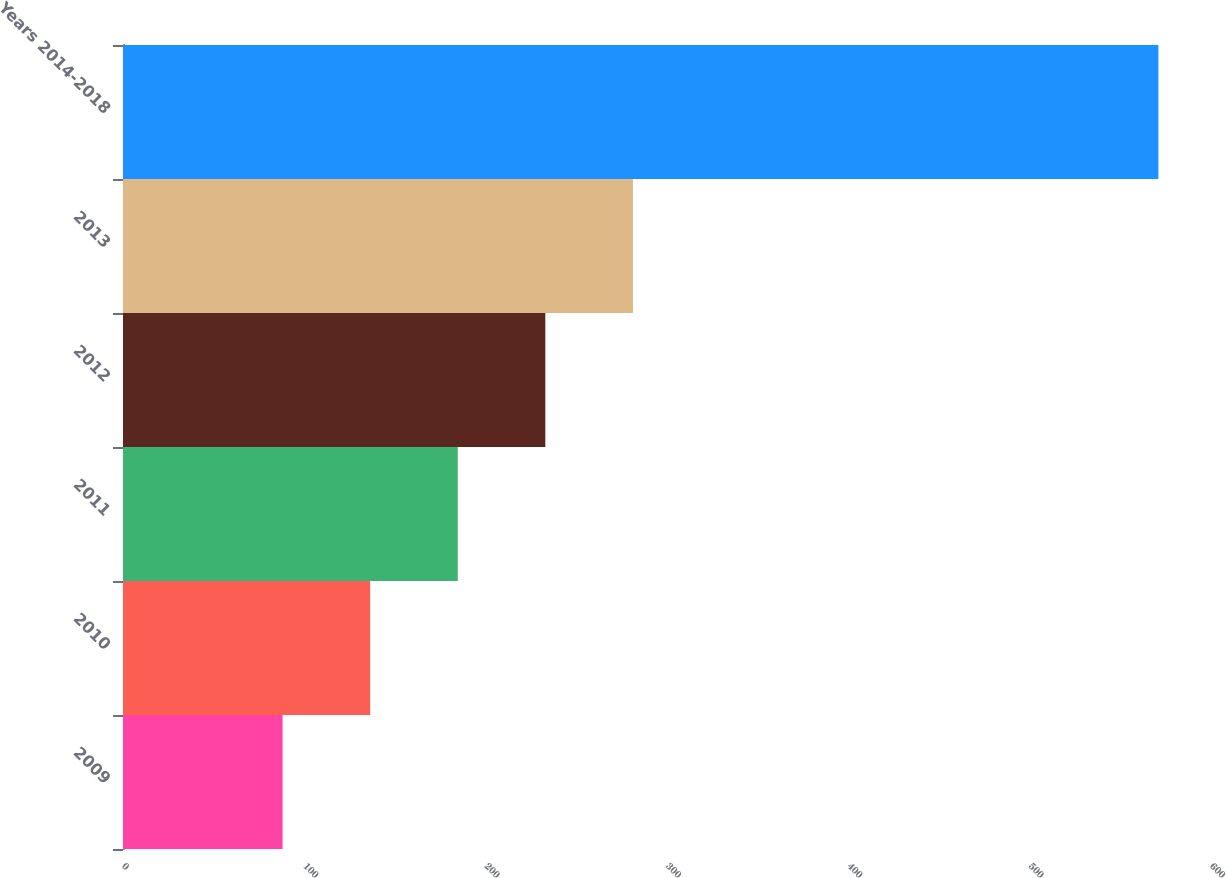Convert chart to OTSL. <chart><loc_0><loc_0><loc_500><loc_500><bar_chart><fcel>2009<fcel>2010<fcel>2011<fcel>2012<fcel>2013<fcel>Years 2014-2018<nl><fcel>88<fcel>136.3<fcel>184.6<fcel>232.9<fcel>281.2<fcel>571<nl></chart> 